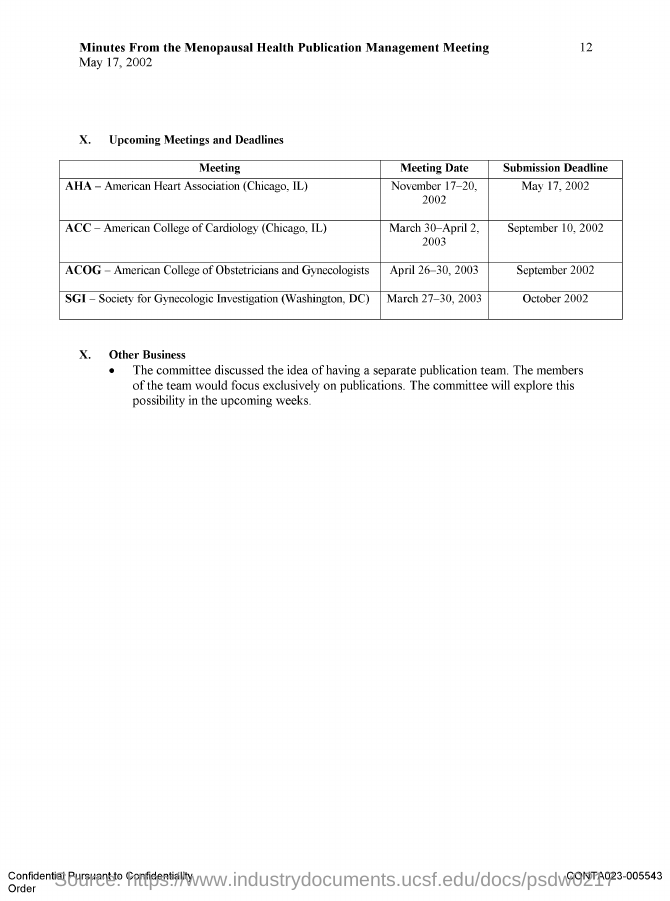What is the Page Number?
Your answer should be very brief. 12. What is the title of the document?
Your answer should be very brief. Minutes from the menopausal health publication management meeting. 